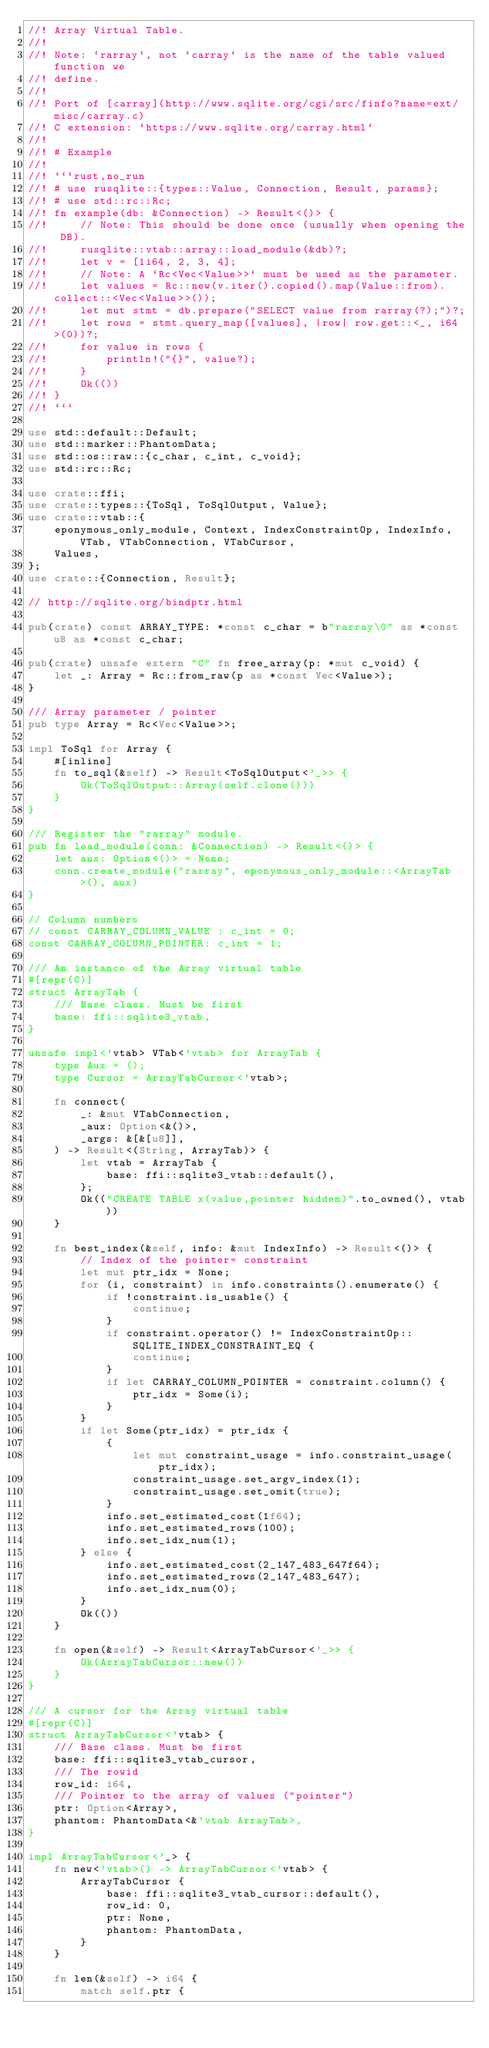Convert code to text. <code><loc_0><loc_0><loc_500><loc_500><_Rust_>//! Array Virtual Table.
//!
//! Note: `rarray`, not `carray` is the name of the table valued function we
//! define.
//!
//! Port of [carray](http://www.sqlite.org/cgi/src/finfo?name=ext/misc/carray.c)
//! C extension: `https://www.sqlite.org/carray.html`
//!
//! # Example
//!
//! ```rust,no_run
//! # use rusqlite::{types::Value, Connection, Result, params};
//! # use std::rc::Rc;
//! fn example(db: &Connection) -> Result<()> {
//!     // Note: This should be done once (usually when opening the DB).
//!     rusqlite::vtab::array::load_module(&db)?;
//!     let v = [1i64, 2, 3, 4];
//!     // Note: A `Rc<Vec<Value>>` must be used as the parameter.
//!     let values = Rc::new(v.iter().copied().map(Value::from).collect::<Vec<Value>>());
//!     let mut stmt = db.prepare("SELECT value from rarray(?);")?;
//!     let rows = stmt.query_map([values], |row| row.get::<_, i64>(0))?;
//!     for value in rows {
//!         println!("{}", value?);
//!     }
//!     Ok(())
//! }
//! ```

use std::default::Default;
use std::marker::PhantomData;
use std::os::raw::{c_char, c_int, c_void};
use std::rc::Rc;

use crate::ffi;
use crate::types::{ToSql, ToSqlOutput, Value};
use crate::vtab::{
    eponymous_only_module, Context, IndexConstraintOp, IndexInfo, VTab, VTabConnection, VTabCursor,
    Values,
};
use crate::{Connection, Result};

// http://sqlite.org/bindptr.html

pub(crate) const ARRAY_TYPE: *const c_char = b"rarray\0" as *const u8 as *const c_char;

pub(crate) unsafe extern "C" fn free_array(p: *mut c_void) {
    let _: Array = Rc::from_raw(p as *const Vec<Value>);
}

/// Array parameter / pointer
pub type Array = Rc<Vec<Value>>;

impl ToSql for Array {
    #[inline]
    fn to_sql(&self) -> Result<ToSqlOutput<'_>> {
        Ok(ToSqlOutput::Array(self.clone()))
    }
}

/// Register the "rarray" module.
pub fn load_module(conn: &Connection) -> Result<()> {
    let aux: Option<()> = None;
    conn.create_module("rarray", eponymous_only_module::<ArrayTab>(), aux)
}

// Column numbers
// const CARRAY_COLUMN_VALUE : c_int = 0;
const CARRAY_COLUMN_POINTER: c_int = 1;

/// An instance of the Array virtual table
#[repr(C)]
struct ArrayTab {
    /// Base class. Must be first
    base: ffi::sqlite3_vtab,
}

unsafe impl<'vtab> VTab<'vtab> for ArrayTab {
    type Aux = ();
    type Cursor = ArrayTabCursor<'vtab>;

    fn connect(
        _: &mut VTabConnection,
        _aux: Option<&()>,
        _args: &[&[u8]],
    ) -> Result<(String, ArrayTab)> {
        let vtab = ArrayTab {
            base: ffi::sqlite3_vtab::default(),
        };
        Ok(("CREATE TABLE x(value,pointer hidden)".to_owned(), vtab))
    }

    fn best_index(&self, info: &mut IndexInfo) -> Result<()> {
        // Index of the pointer= constraint
        let mut ptr_idx = None;
        for (i, constraint) in info.constraints().enumerate() {
            if !constraint.is_usable() {
                continue;
            }
            if constraint.operator() != IndexConstraintOp::SQLITE_INDEX_CONSTRAINT_EQ {
                continue;
            }
            if let CARRAY_COLUMN_POINTER = constraint.column() {
                ptr_idx = Some(i);
            }
        }
        if let Some(ptr_idx) = ptr_idx {
            {
                let mut constraint_usage = info.constraint_usage(ptr_idx);
                constraint_usage.set_argv_index(1);
                constraint_usage.set_omit(true);
            }
            info.set_estimated_cost(1f64);
            info.set_estimated_rows(100);
            info.set_idx_num(1);
        } else {
            info.set_estimated_cost(2_147_483_647f64);
            info.set_estimated_rows(2_147_483_647);
            info.set_idx_num(0);
        }
        Ok(())
    }

    fn open(&self) -> Result<ArrayTabCursor<'_>> {
        Ok(ArrayTabCursor::new())
    }
}

/// A cursor for the Array virtual table
#[repr(C)]
struct ArrayTabCursor<'vtab> {
    /// Base class. Must be first
    base: ffi::sqlite3_vtab_cursor,
    /// The rowid
    row_id: i64,
    /// Pointer to the array of values ("pointer")
    ptr: Option<Array>,
    phantom: PhantomData<&'vtab ArrayTab>,
}

impl ArrayTabCursor<'_> {
    fn new<'vtab>() -> ArrayTabCursor<'vtab> {
        ArrayTabCursor {
            base: ffi::sqlite3_vtab_cursor::default(),
            row_id: 0,
            ptr: None,
            phantom: PhantomData,
        }
    }

    fn len(&self) -> i64 {
        match self.ptr {</code> 